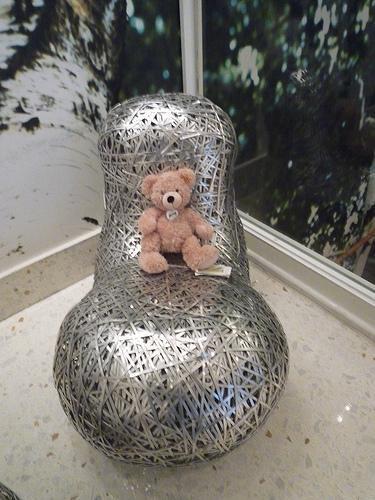How many teddy bears are wearing glasses?
Give a very brief answer. 0. 